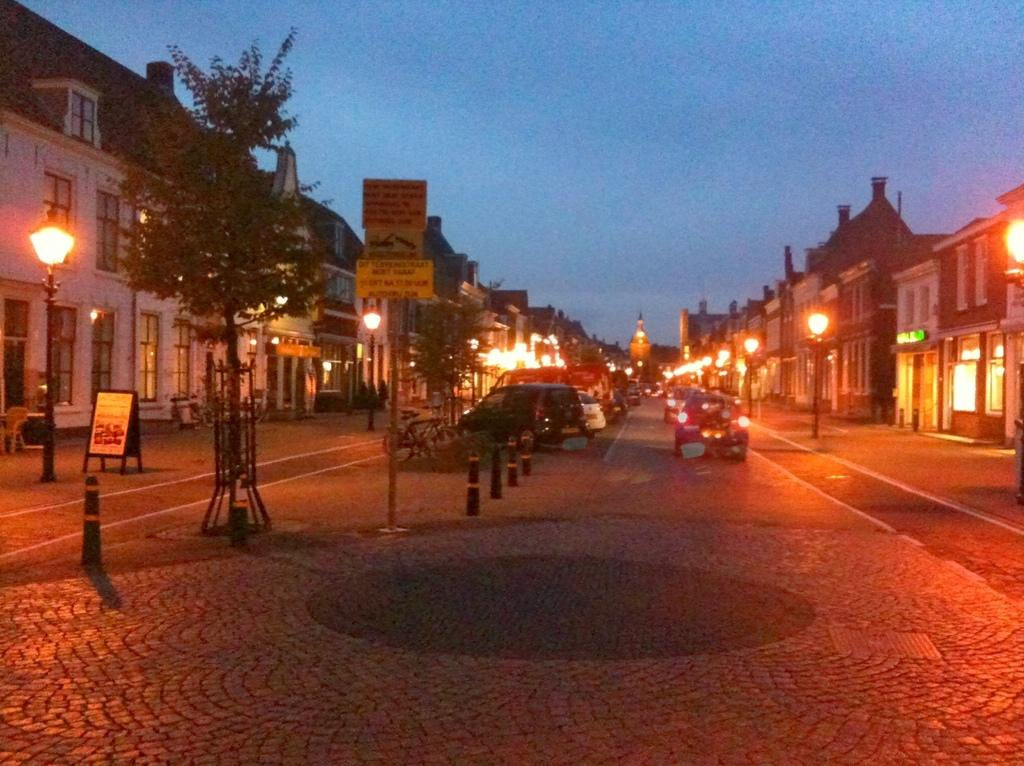What type of vehicles can be seen on the road in the image? There are motor vehicles on the road in the image. What structures are present in the image besides the vehicles? Poles, information boards, street poles, street lights, buildings, and trees are visible in the image. What part of the natural environment is visible in the image? Trees and the sky are visible in the image. What historical event is being commemorated by the page in the image? There is no page present in the image, and therefore no historical event can be associated with it. 